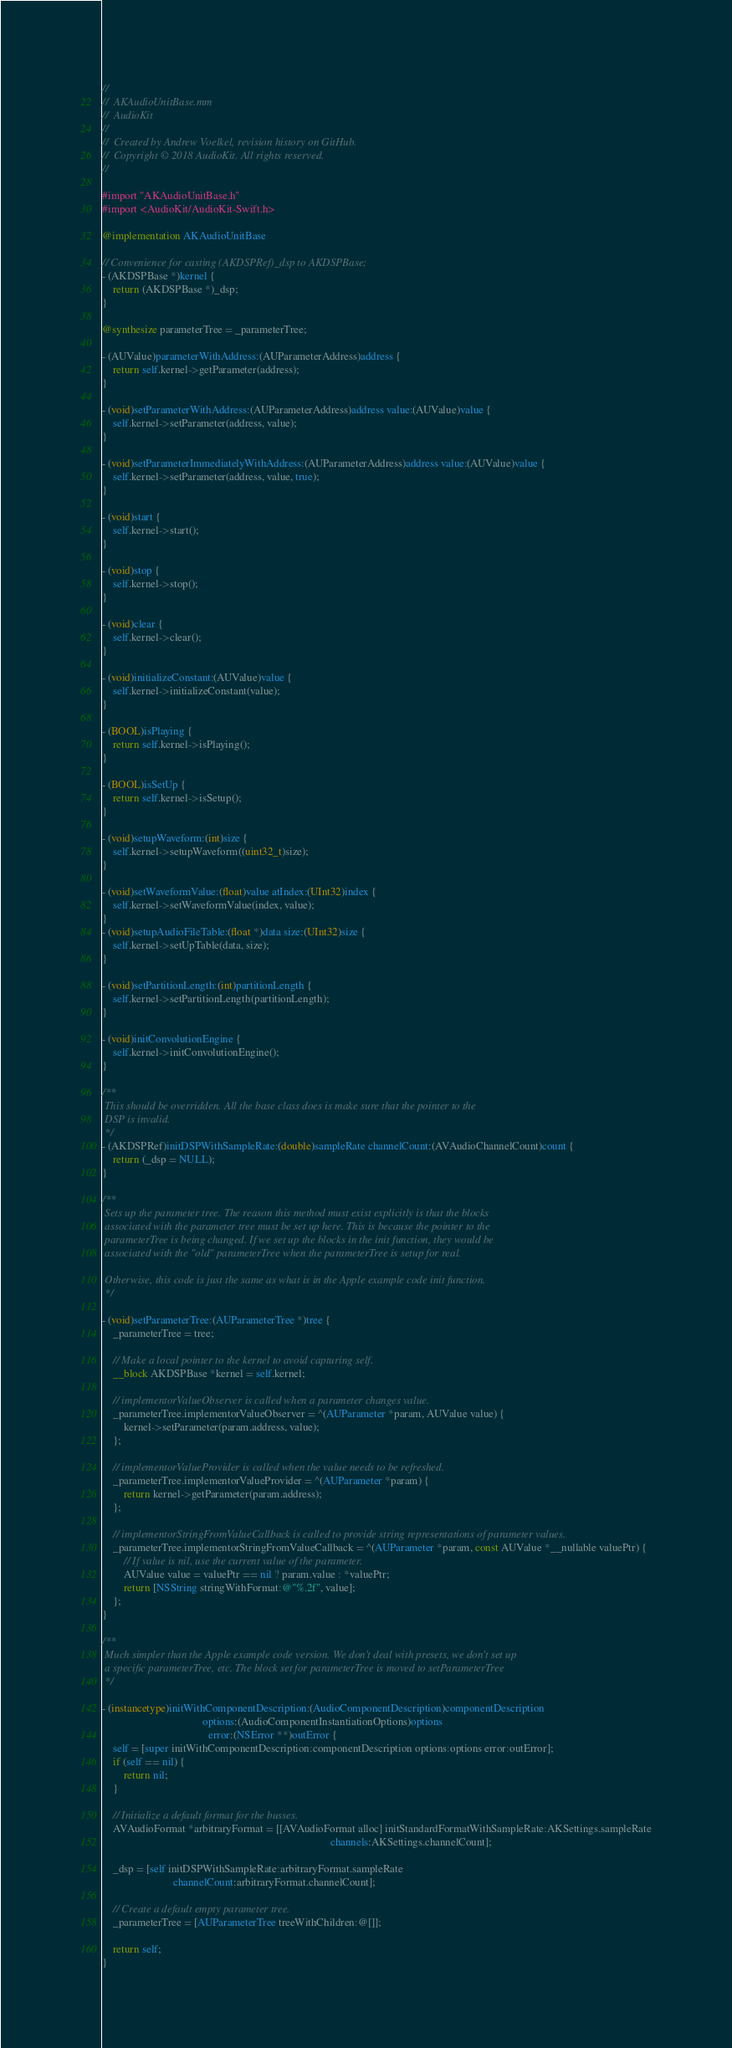Convert code to text. <code><loc_0><loc_0><loc_500><loc_500><_ObjectiveC_>//
//  AKAudioUnitBase.mm
//  AudioKit
//
//  Created by Andrew Voelkel, revision history on GitHub.
//  Copyright © 2018 AudioKit. All rights reserved.
//

#import "AKAudioUnitBase.h"
#import <AudioKit/AudioKit-Swift.h>

@implementation AKAudioUnitBase

// Convenience for casting (AKDSPRef)_dsp to AKDSPBase;
- (AKDSPBase *)kernel {
    return (AKDSPBase *)_dsp;
}

@synthesize parameterTree = _parameterTree;

- (AUValue)parameterWithAddress:(AUParameterAddress)address {
    return self.kernel->getParameter(address);
}

- (void)setParameterWithAddress:(AUParameterAddress)address value:(AUValue)value {
    self.kernel->setParameter(address, value);
}

- (void)setParameterImmediatelyWithAddress:(AUParameterAddress)address value:(AUValue)value {
    self.kernel->setParameter(address, value, true);
}

- (void)start {
    self.kernel->start();
}

- (void)stop {
    self.kernel->stop();
}

- (void)clear {
    self.kernel->clear();
}

- (void)initializeConstant:(AUValue)value {
    self.kernel->initializeConstant(value);
}

- (BOOL)isPlaying {
    return self.kernel->isPlaying();
}

- (BOOL)isSetUp {
    return self.kernel->isSetup();
}

- (void)setupWaveform:(int)size {
    self.kernel->setupWaveform((uint32_t)size);
}

- (void)setWaveformValue:(float)value atIndex:(UInt32)index {
    self.kernel->setWaveformValue(index, value);
}
- (void)setupAudioFileTable:(float *)data size:(UInt32)size {
    self.kernel->setUpTable(data, size);
}

- (void)setPartitionLength:(int)partitionLength {
    self.kernel->setPartitionLength(partitionLength);
}

- (void)initConvolutionEngine {
    self.kernel->initConvolutionEngine();
}

/**
 This should be overridden. All the base class does is make sure that the pointer to the
 DSP is invalid.
 */
- (AKDSPRef)initDSPWithSampleRate:(double)sampleRate channelCount:(AVAudioChannelCount)count {
    return (_dsp = NULL);
}

/**
 Sets up the parameter tree. The reason this method must exist explicitly is that the blocks
 associated with the parameter tree must be set up here. This is because the pointer to the
 parameterTree is being changed. If we set up the blocks in the init function, they would be
 associated with the "old" parameterTree when the parameterTree is setup for real.

 Otherwise, this code is just the same as what is in the Apple example code init function.
 */

- (void)setParameterTree:(AUParameterTree *)tree {
    _parameterTree = tree;

    // Make a local pointer to the kernel to avoid capturing self.
    __block AKDSPBase *kernel = self.kernel;

    // implementorValueObserver is called when a parameter changes value.
    _parameterTree.implementorValueObserver = ^(AUParameter *param, AUValue value) {
        kernel->setParameter(param.address, value);
    };

    // implementorValueProvider is called when the value needs to be refreshed.
    _parameterTree.implementorValueProvider = ^(AUParameter *param) {
        return kernel->getParameter(param.address);
    };

    // implementorStringFromValueCallback is called to provide string representations of parameter values.
    _parameterTree.implementorStringFromValueCallback = ^(AUParameter *param, const AUValue *__nullable valuePtr) {
        // If value is nil, use the current value of the parameter.
        AUValue value = valuePtr == nil ? param.value : *valuePtr;
        return [NSString stringWithFormat:@"%.2f", value];
    };
}

/**
 Much simpler than the Apple example code version. We don't deal with presets, we don't set up
 a specific parameterTree, etc. The block set for parameterTree is moved to setParameterTree
 */

- (instancetype)initWithComponentDescription:(AudioComponentDescription)componentDescription
                                     options:(AudioComponentInstantiationOptions)options
                                       error:(NSError **)outError {
    self = [super initWithComponentDescription:componentDescription options:options error:outError];
    if (self == nil) {
        return nil;
    }

    // Initialize a default format for the busses.
    AVAudioFormat *arbitraryFormat = [[AVAudioFormat alloc] initStandardFormatWithSampleRate:AKSettings.sampleRate
                                                                                    channels:AKSettings.channelCount];

    _dsp = [self initDSPWithSampleRate:arbitraryFormat.sampleRate
                          channelCount:arbitraryFormat.channelCount];

    // Create a default empty parameter tree.
    _parameterTree = [AUParameterTree treeWithChildren:@[]];

    return self;
}
</code> 